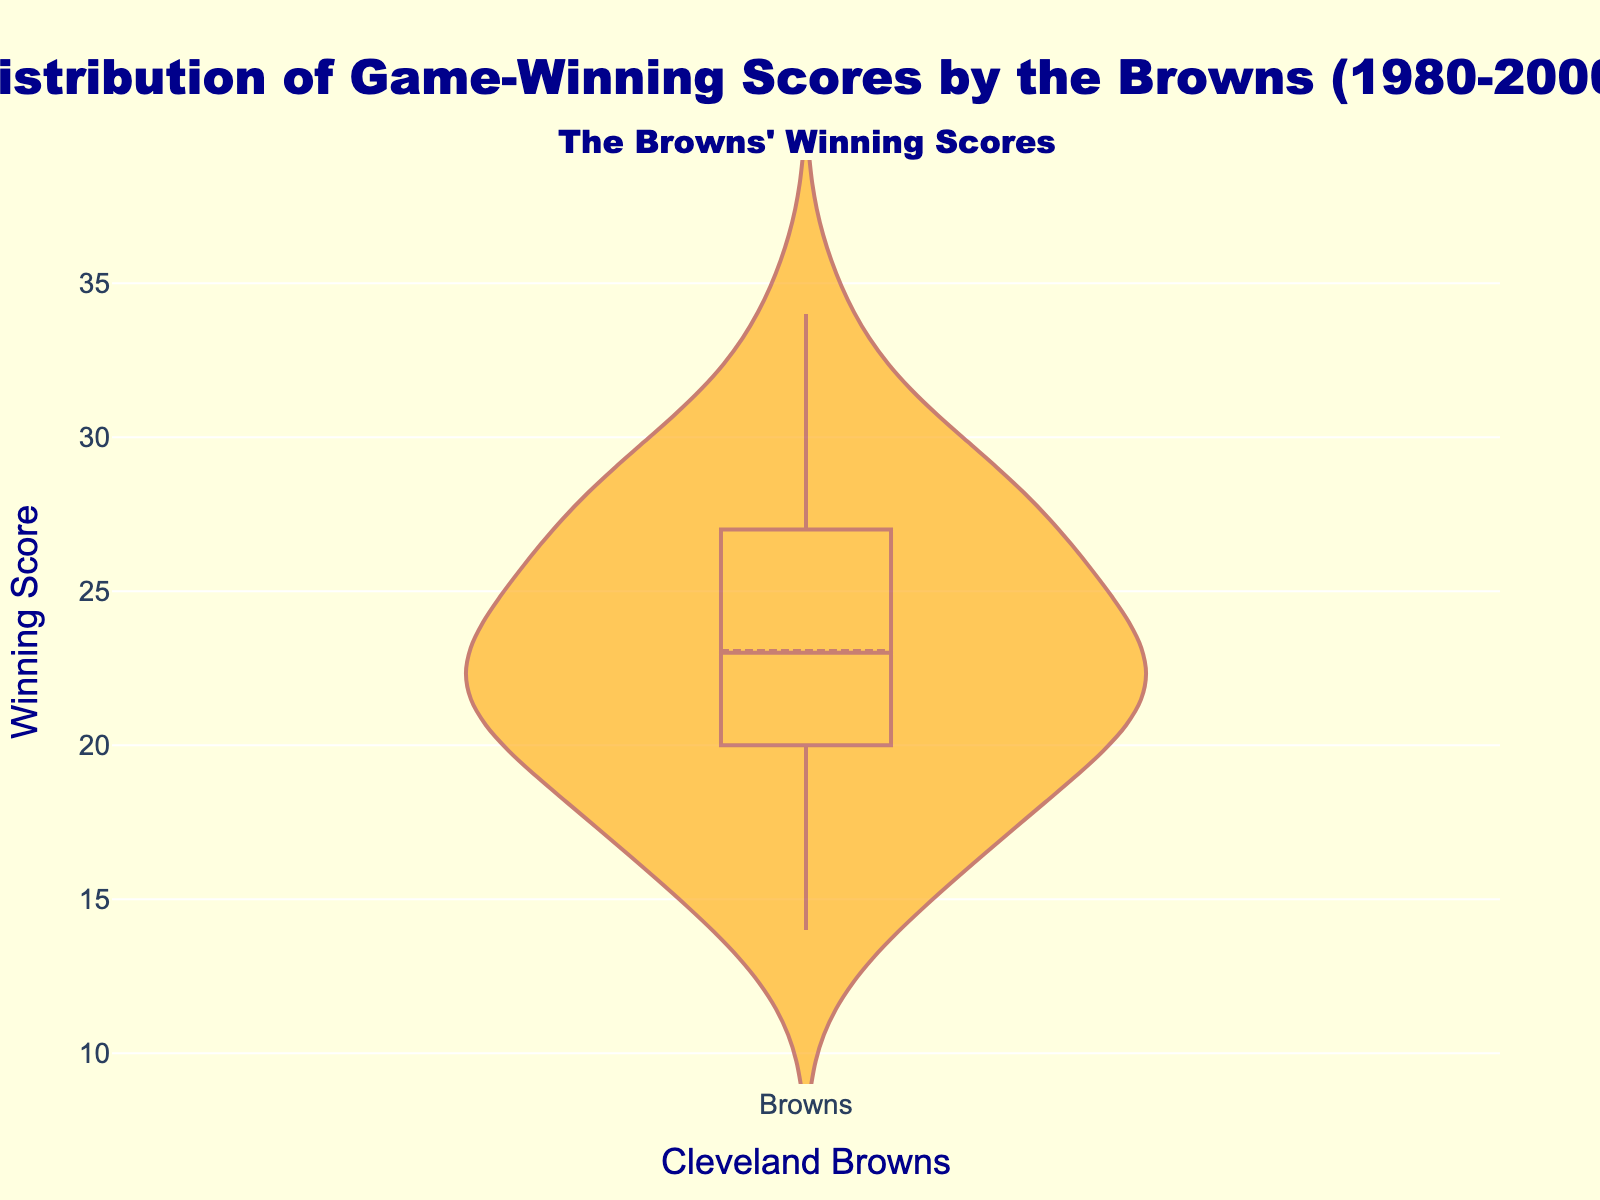What's the main title of the figure? The main title of the figure is clearly written on top. It indicates the subject of the data presented.
Answer: Distribution of Game-Winning Scores by the Browns (1980-2000) What is displayed along the y-axis? The y-axis represents the winning scores during the games. This axis shows the range of scores the Browns achieved when they won.
Answer: Winning Score What colors are used in the figure? The figure uses brown for the outline and orange for the filling of the violin plot. The background is light yellow with dark blue text.
Answer: Brown, orange, light yellow, dark blue How many winning scores are illustrated in the plot? By counting the number of data points in the dataset, you can determine the number of winning scores shown. There are 32 data points, each representing a winning score from the fulfilled seasons between 1980-2000.
Answer: 32 Which season had the highest game-winning score, according to the dataset? By reviewing the dataset, the highest score corresponds to a specific season and game. The score of 34 points occurred in the 1990 season, game 2.
Answer: 1990 What is the median winning score during this period? The violin plot displays a mean line and a median line. Identify the median line's position along the y-axis to determine the value.
Answer: Approximately 23 During which years did the Browns have a winning score of exactly 21 points? By inspecting the dataset, look for all instances where the winning score equals 21 and note the corresponding seasons. The seasons are 1982 (game 2), 1985 (game 1), 1991 (game 9), and 2000 (game 8).
Answer: 1982, 1985, 1991, 2000 Are the winning scores more densely distributed at higher or lower values? Reviewing the density of the points within the violin plot, note where there is a greater concentration of scores. The plot is denser around the lower values.
Answer: Lower values What is the range of winning scores presented in the figure? The y-axis displays the lowest and highest scores, which gives the range of values shown in the distribution plot. Subtract the minimum score (14) from the maximum score (34).
Answer: 20 What can you infer about the variability of the Browns' winning scores over the two decades? By analyzing the distribution width of the violin plot, consider how spread out the scores are. A wider spread indicates higher variability. The width of the plot suggests that there is a moderate variability in the scores.
Answer: Moderate variability 